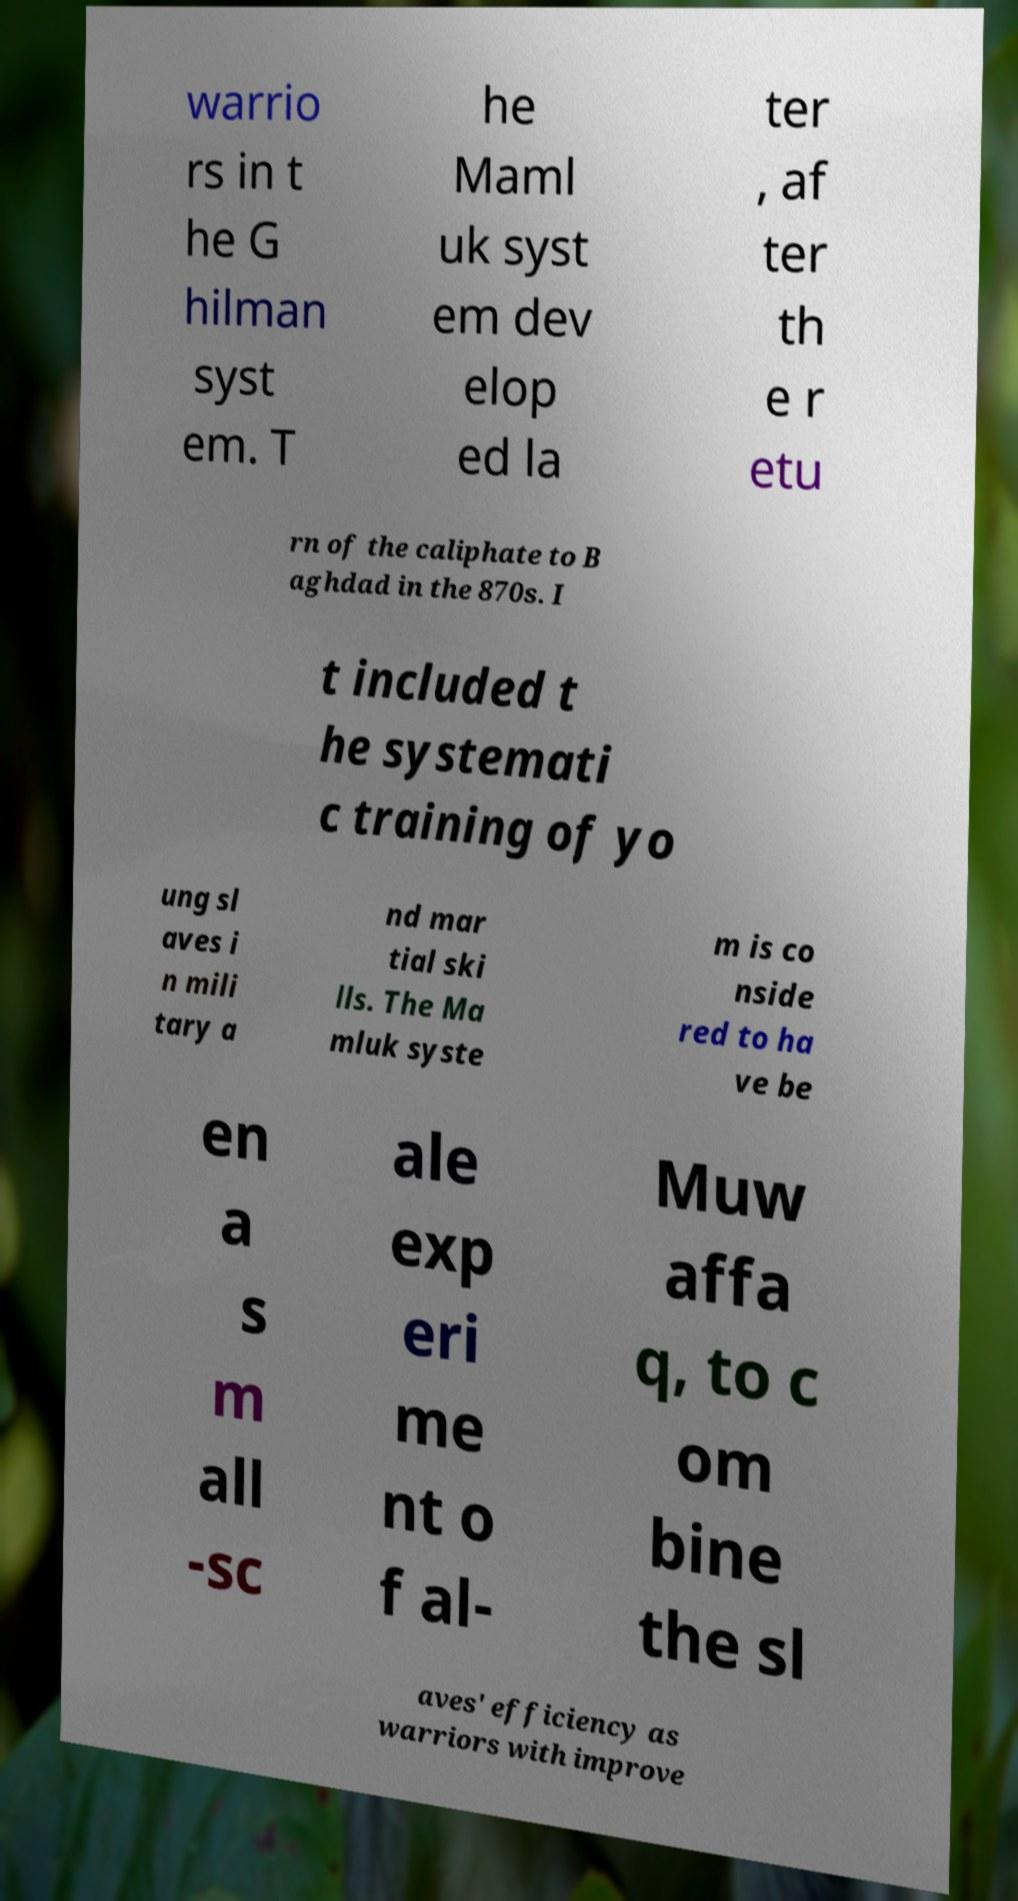Can you read and provide the text displayed in the image?This photo seems to have some interesting text. Can you extract and type it out for me? warrio rs in t he G hilman syst em. T he Maml uk syst em dev elop ed la ter , af ter th e r etu rn of the caliphate to B aghdad in the 870s. I t included t he systemati c training of yo ung sl aves i n mili tary a nd mar tial ski lls. The Ma mluk syste m is co nside red to ha ve be en a s m all -sc ale exp eri me nt o f al- Muw affa q, to c om bine the sl aves' efficiency as warriors with improve 